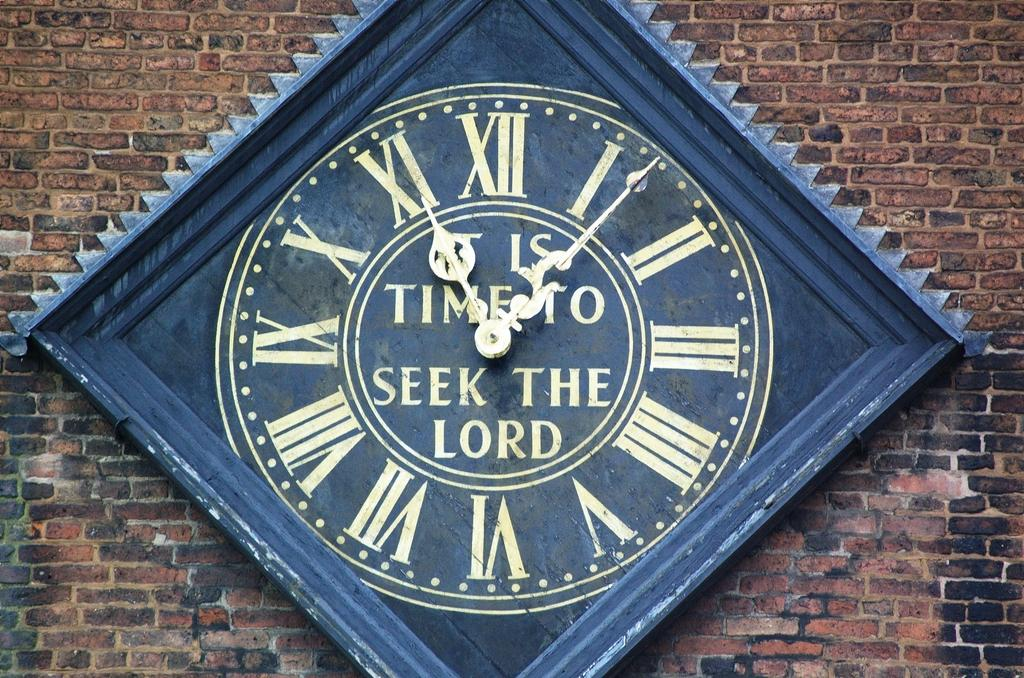<image>
Render a clear and concise summary of the photo. a clock with It is time to seek the lord on the face 